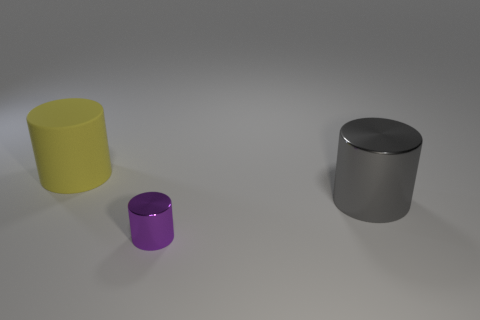Is there any other thing that has the same material as the big yellow cylinder?
Keep it short and to the point. No. There is a purple object that is the same shape as the yellow object; what is its size?
Give a very brief answer. Small. Are there fewer gray objects behind the large yellow matte cylinder than large gray shiny objects right of the tiny thing?
Keep it short and to the point. Yes. What shape is the object that is behind the small purple metal cylinder and right of the big yellow matte object?
Make the answer very short. Cylinder. What size is the purple thing that is made of the same material as the gray cylinder?
Keep it short and to the point. Small. The cylinder that is on the left side of the gray shiny cylinder and behind the tiny cylinder is made of what material?
Ensure brevity in your answer.  Rubber. There is a large object in front of the yellow matte object; is it the same shape as the thing that is left of the tiny thing?
Ensure brevity in your answer.  Yes. Are any small gray cylinders visible?
Your answer should be compact. No. What is the color of the tiny metal thing that is the same shape as the big yellow rubber object?
Your answer should be very brief. Purple. What is the color of the other object that is the same size as the gray thing?
Keep it short and to the point. Yellow. 